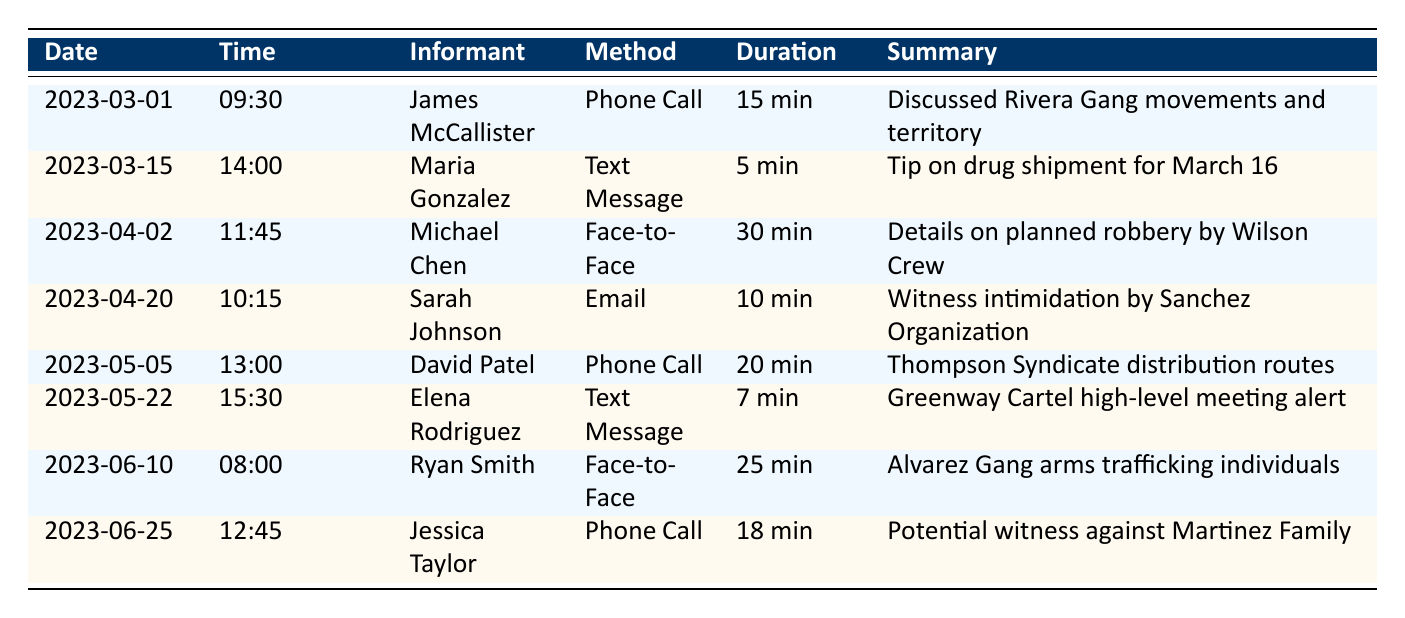What date did James McCallister provide information about the Rivera Gang? The log indicates that James McCallister's communication occurred on March 1, 2023. Thus, the date he provided information about the Rivera Gang is 2023-03-01.
Answer: 2023-03-01 How many minutes did Maria Gonzalez spend communicating in total? Maria Gonzalez's communication was a text message with a duration of 5 minutes. As there's only one entry for her, the total duration is simply 5 minutes.
Answer: 5 minutes Was there any communication regarding witness intimidation? Yes, there was communication on April 20, 2023, by Sarah Johnson, who informed about potential witness intimidation by the Sanchez Organization.
Answer: Yes Identify the informant who discussed a planned robbery and provide the method used. Michael Chen discussed a planned robbery by the Wilson Crew on April 2, 2023, using the method of a face-to-face meeting.
Answer: Michael Chen, Face-to-Face Meeting What was the total duration of phone calls made by informants? There were three phone calls recorded: James McCallister (15 minutes), David Patel (20 minutes), and Jessica Taylor (18 minutes). Summing these: 15 + 20 + 18 = 53 minutes, so the total duration of phone calls is 53 minutes.
Answer: 53 minutes On which date did Elena Rodriguez alert about a Greenway Cartel meeting? Elena Rodriguez sent a text message alerting about a meeting of high-level members of the Greenway Cartel on May 22, 2023.
Answer: 2023-05-22 How many informants used a text message method of communication? There are two entries for text message communication: Maria Gonzalez on March 15 and Elena Rodriguez on May 22. Therefore, the total number of informants using text messages is 2.
Answer: 2 Was any information shared about arms trafficking? Yes, Ryan Smith provided names of individuals involved in arms trafficking with the Alvarez Gang during a face-to-face meeting on June 10, 2023.
Answer: Yes What is the average duration of face-to-face meetings reported? There were two face-to-face meetings: Michael Chen for 30 minutes and Ryan Smith for 25 minutes. The average duration is (30 + 25) / 2 = 27.5 minutes.
Answer: 27.5 minutes 